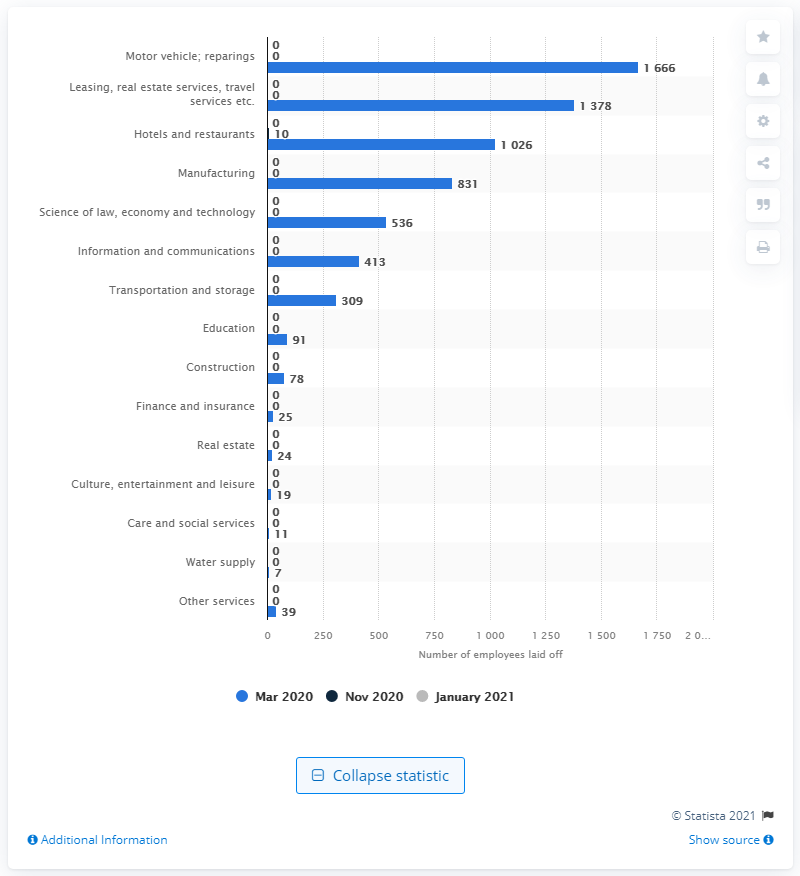Mention a couple of crucial points in this snapshot. In November, there were layoffs experienced by people in the hotel and restaurant industry. Layoffs were registered in Sweden in January 2021. 